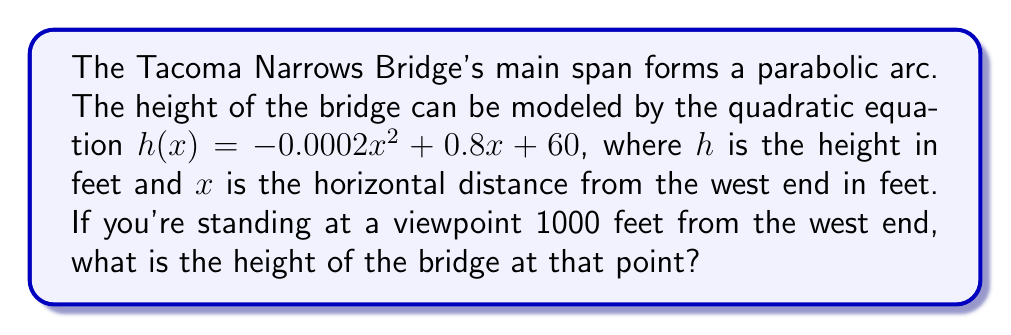Could you help me with this problem? To solve this problem, we'll follow these steps:

1) We're given the quadratic equation for the bridge's arc:
   $h(x) = -0.0002x^2 + 0.8x + 60$

2) We need to find the height at $x = 1000$ feet from the west end.

3) Let's substitute $x = 1000$ into the equation:

   $h(1000) = -0.0002(1000)^2 + 0.8(1000) + 60$

4) Now, let's calculate each term:
   $-0.0002(1000)^2 = -0.0002(1,000,000) = -200$
   $0.8(1000) = 800$
   The constant term is already 60

5) Add these terms:
   $h(1000) = -200 + 800 + 60 = 660$

Therefore, the height of the bridge at 1000 feet from the west end is 660 feet.
Answer: 660 feet 